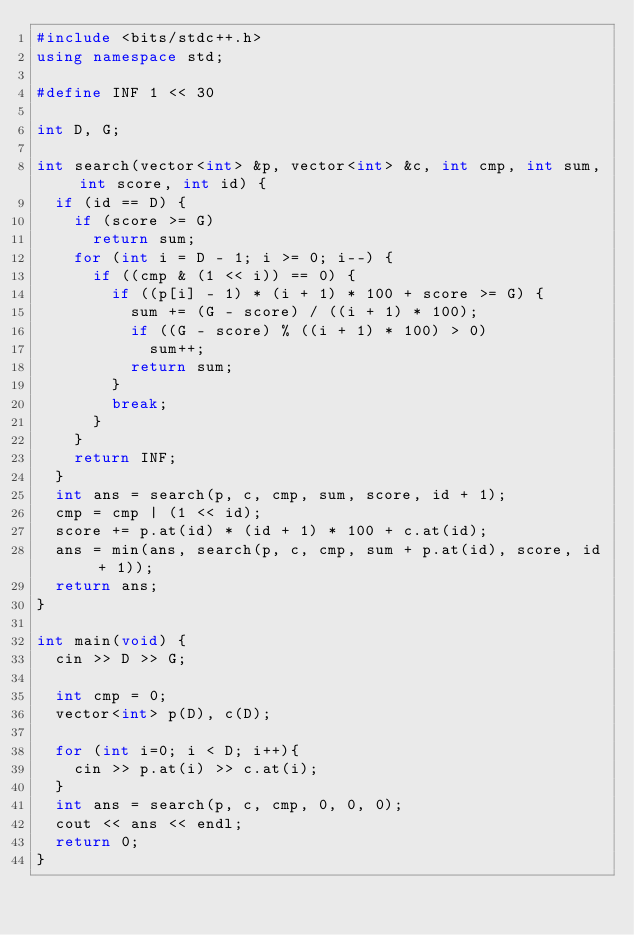<code> <loc_0><loc_0><loc_500><loc_500><_C++_>#include <bits/stdc++.h>
using namespace std;

#define INF 1 << 30

int D, G;

int search(vector<int> &p, vector<int> &c, int cmp, int sum, int score, int id) {
	if (id == D) {
		if (score >= G)
			return sum;
		for (int i = D - 1; i >= 0; i--) {
			if ((cmp & (1 << i)) == 0) {
				if ((p[i] - 1) * (i + 1) * 100 + score >= G) {
					sum += (G - score) / ((i + 1) * 100);
					if ((G - score) % ((i + 1) * 100) > 0)
						sum++;
					return sum;
				}
				break;
			}
		}
		return INF;
	}
	int ans = search(p, c, cmp, sum, score, id + 1);
	cmp = cmp | (1 << id);
	score += p.at(id) * (id + 1) * 100 + c.at(id);
	ans = min(ans, search(p, c, cmp, sum + p.at(id), score, id + 1));
	return ans;
}

int main(void) {
	cin >> D >> G;

	int cmp = 0;
	vector<int> p(D), c(D);

	for (int i=0; i < D; i++){
    cin >> p.at(i) >> c.at(i);
  }
	int ans = search(p, c, cmp, 0, 0, 0);
  cout << ans << endl;
	return 0;
}</code> 